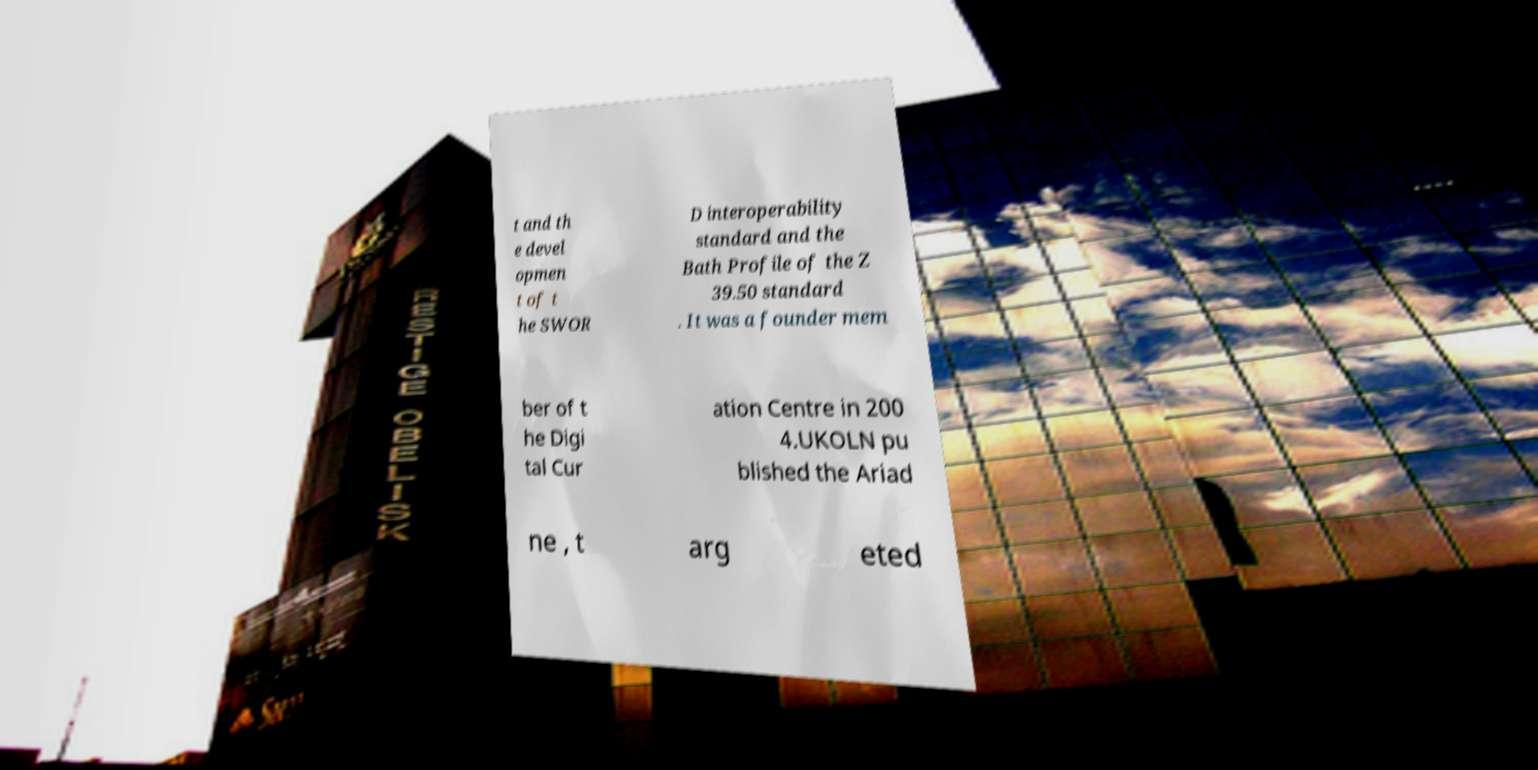Can you read and provide the text displayed in the image?This photo seems to have some interesting text. Can you extract and type it out for me? t and th e devel opmen t of t he SWOR D interoperability standard and the Bath Profile of the Z 39.50 standard . It was a founder mem ber of t he Digi tal Cur ation Centre in 200 4.UKOLN pu blished the Ariad ne , t arg eted 